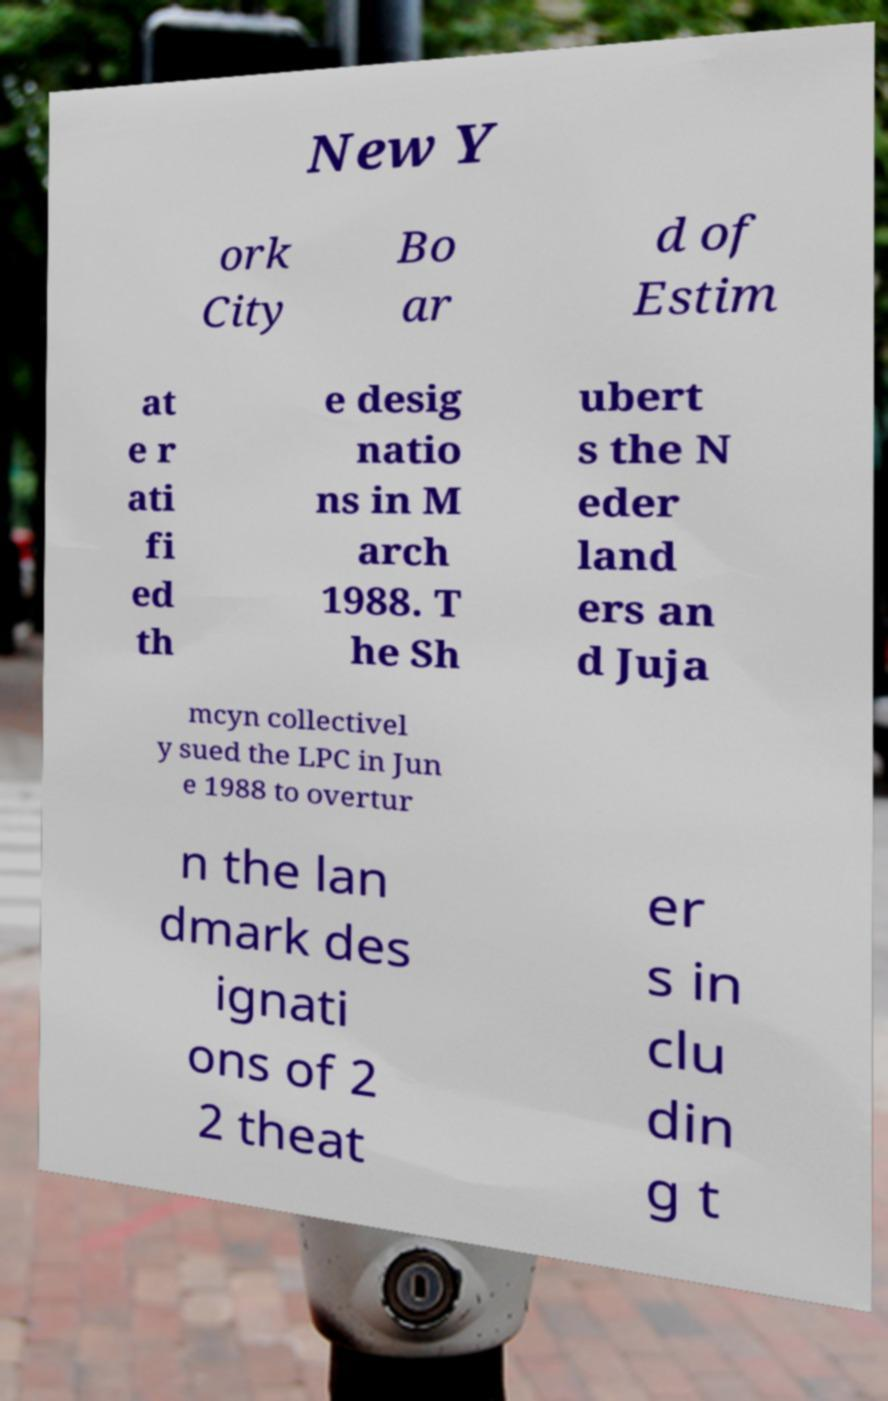I need the written content from this picture converted into text. Can you do that? New Y ork City Bo ar d of Estim at e r ati fi ed th e desig natio ns in M arch 1988. T he Sh ubert s the N eder land ers an d Juja mcyn collectivel y sued the LPC in Jun e 1988 to overtur n the lan dmark des ignati ons of 2 2 theat er s in clu din g t 